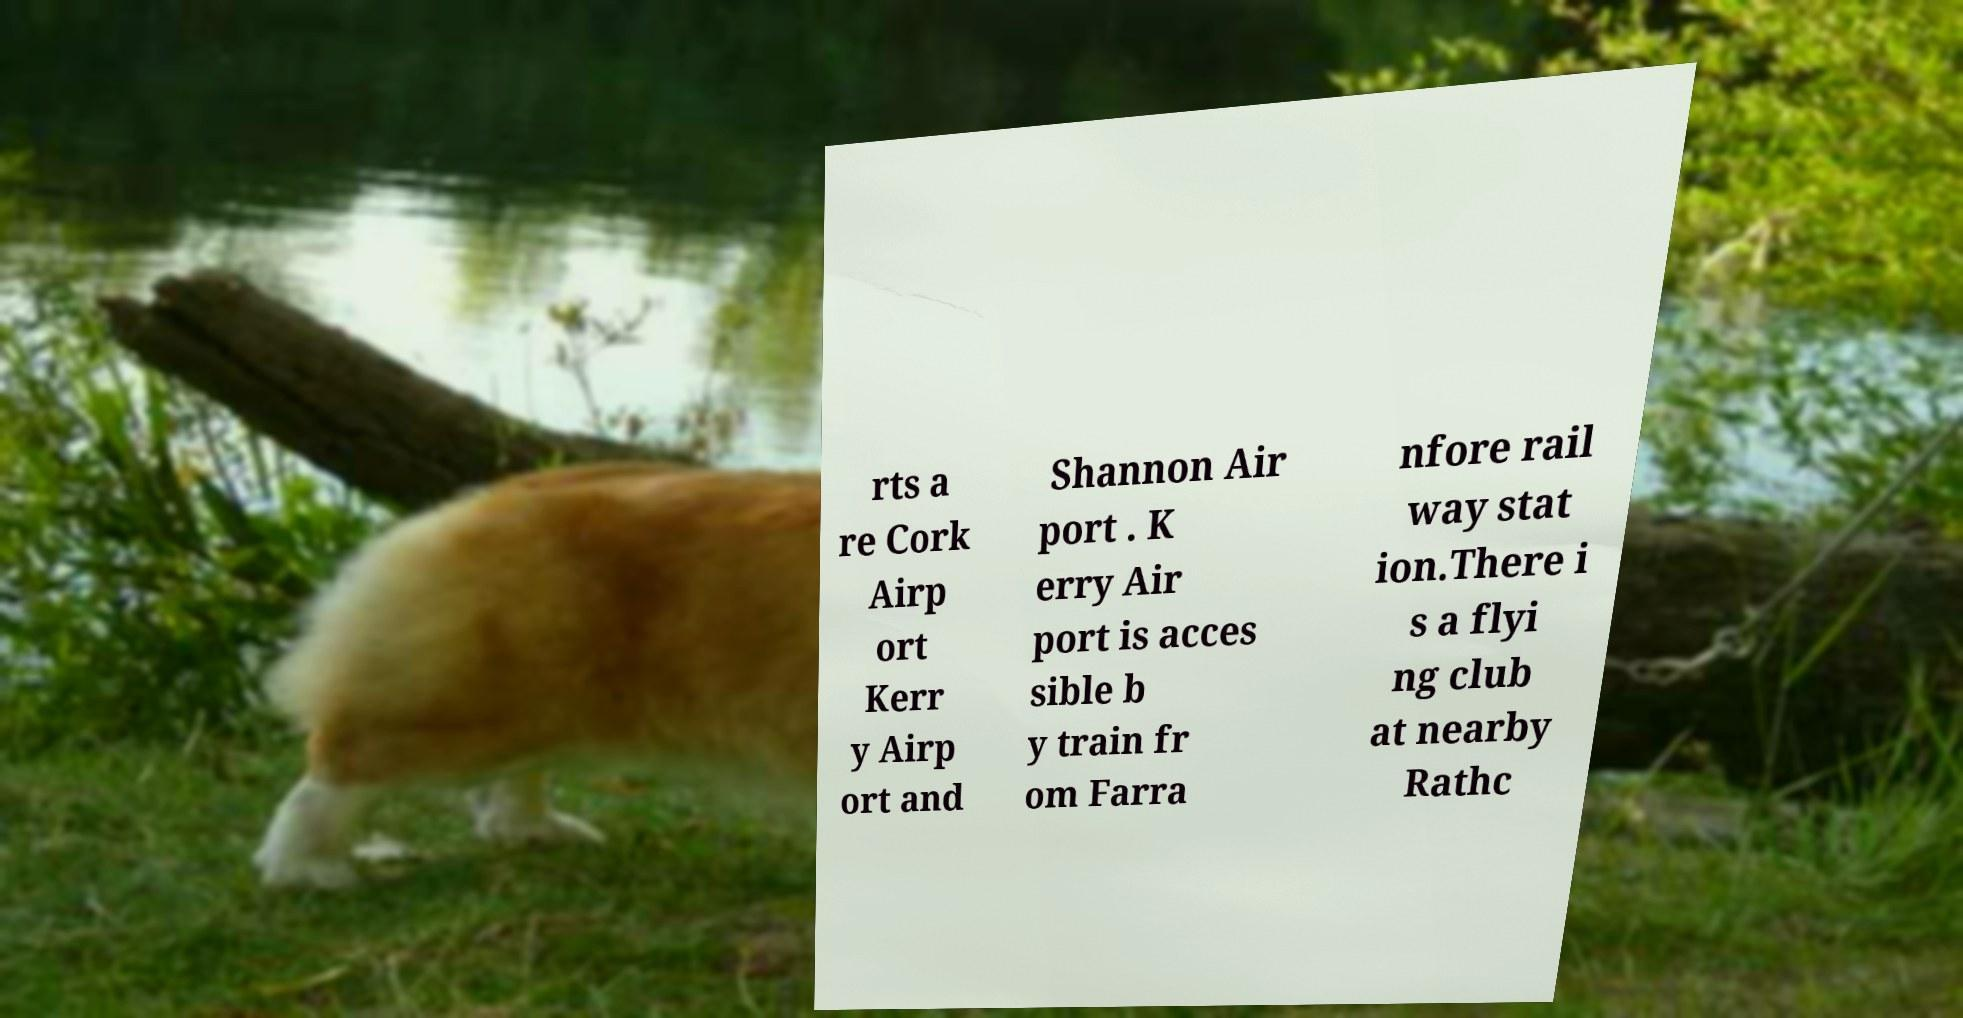Please read and relay the text visible in this image. What does it say? rts a re Cork Airp ort Kerr y Airp ort and Shannon Air port . K erry Air port is acces sible b y train fr om Farra nfore rail way stat ion.There i s a flyi ng club at nearby Rathc 